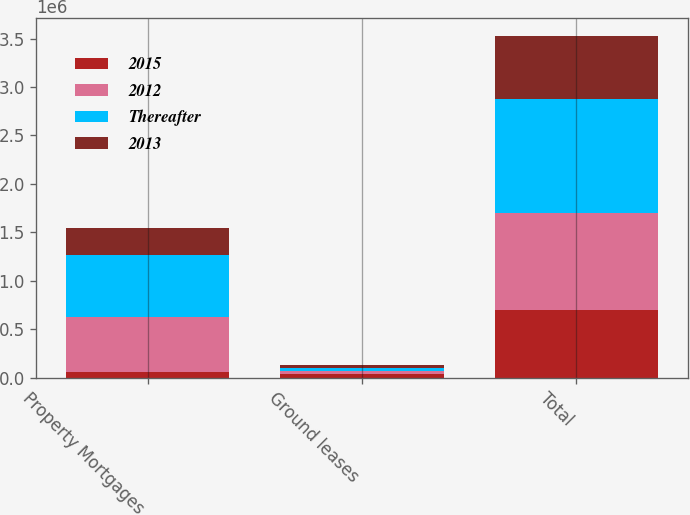Convert chart. <chart><loc_0><loc_0><loc_500><loc_500><stacked_bar_chart><ecel><fcel>Property Mortgages<fcel>Ground leases<fcel>Total<nl><fcel>2015<fcel>52443<fcel>33429<fcel>695979<nl><fcel>2012<fcel>568649<fcel>33429<fcel>1.0066e+06<nl><fcel>Thereafter<fcel>647776<fcel>33429<fcel>1.17461e+06<nl><fcel>2013<fcel>270382<fcel>33429<fcel>653245<nl></chart> 